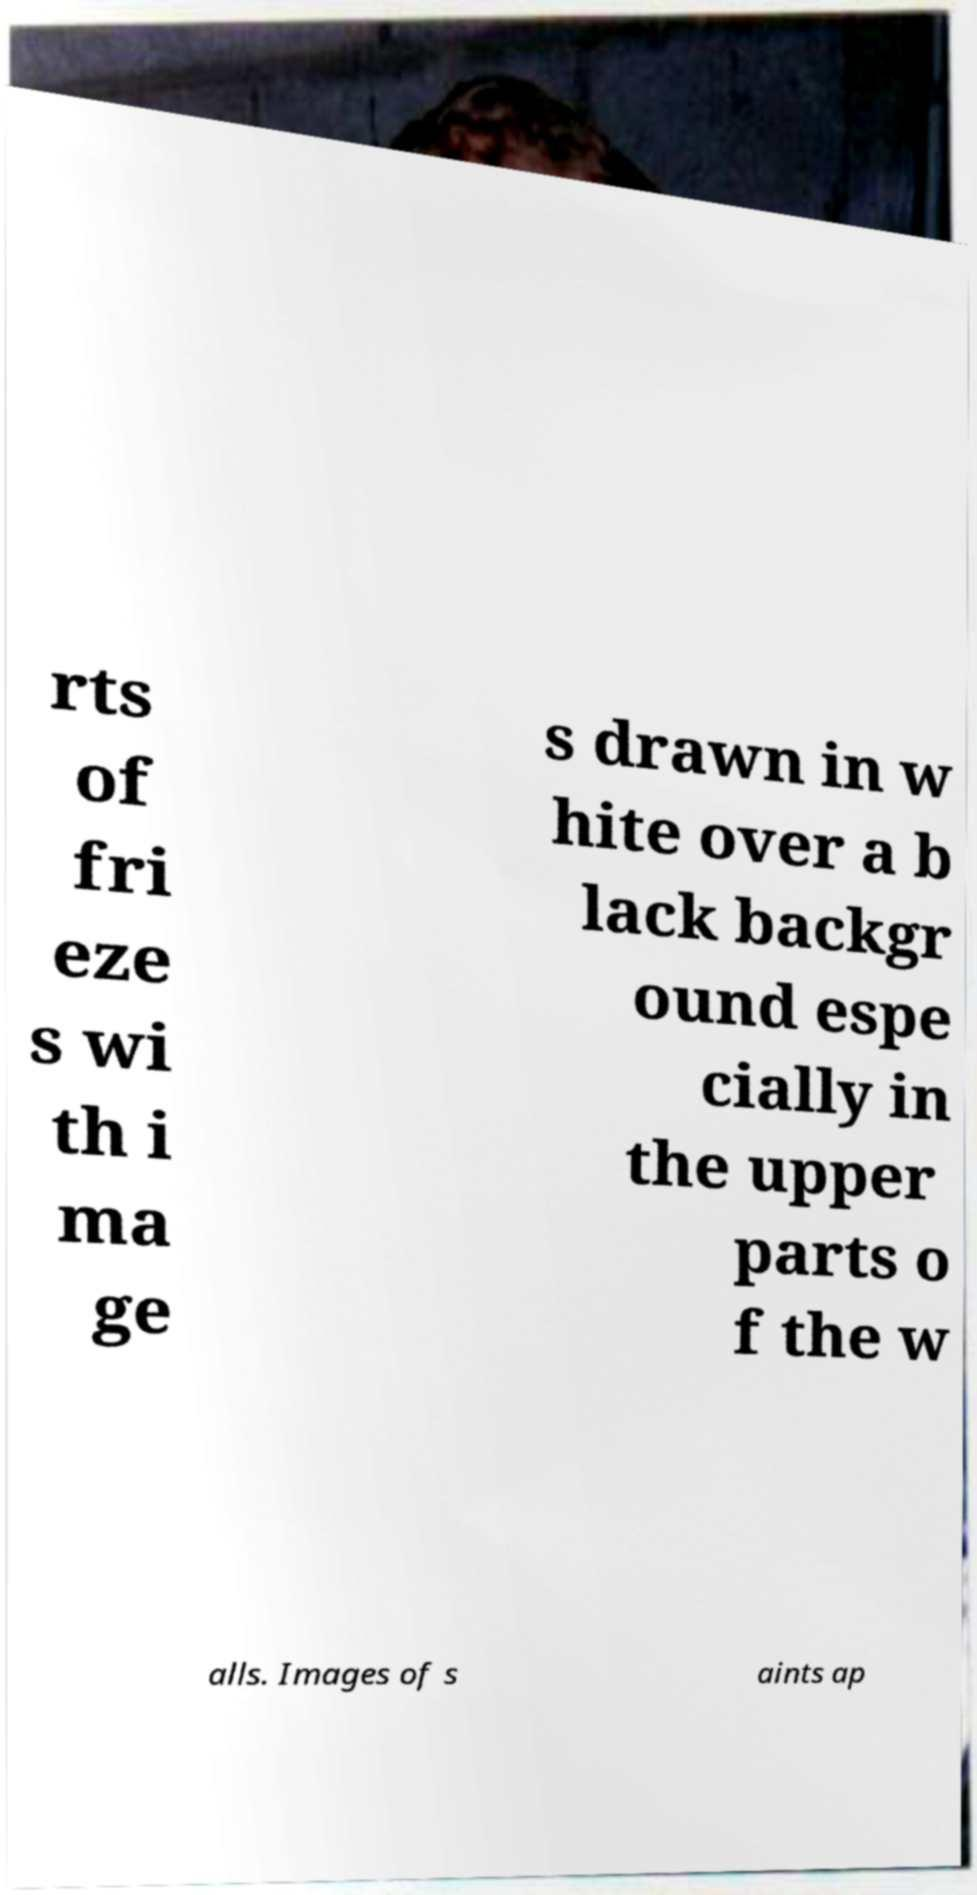Please identify and transcribe the text found in this image. rts of fri eze s wi th i ma ge s drawn in w hite over a b lack backgr ound espe cially in the upper parts o f the w alls. Images of s aints ap 